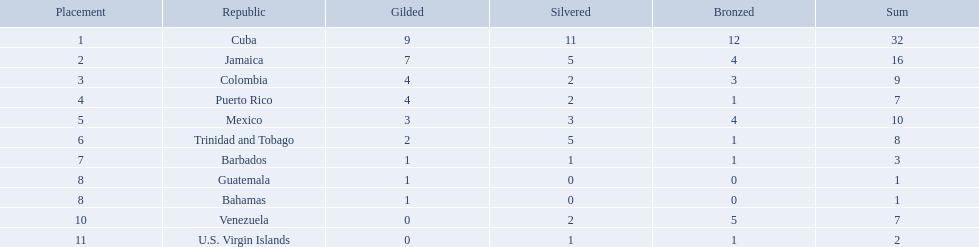Which teams have at exactly 4 gold medals? Colombia, Puerto Rico. Of those teams which has exactly 1 bronze medal? Puerto Rico. What nation has won at least 4 gold medals? Cuba, Jamaica, Colombia, Puerto Rico. Of these countries who has won the least amount of bronze medals? Puerto Rico. Which countries competed in the 1966 central american and caribbean games? Cuba, Jamaica, Colombia, Puerto Rico, Mexico, Trinidad and Tobago, Barbados, Guatemala, Bahamas, Venezuela, U.S. Virgin Islands. Which countries won at least six silver medals at these games? Cuba. 